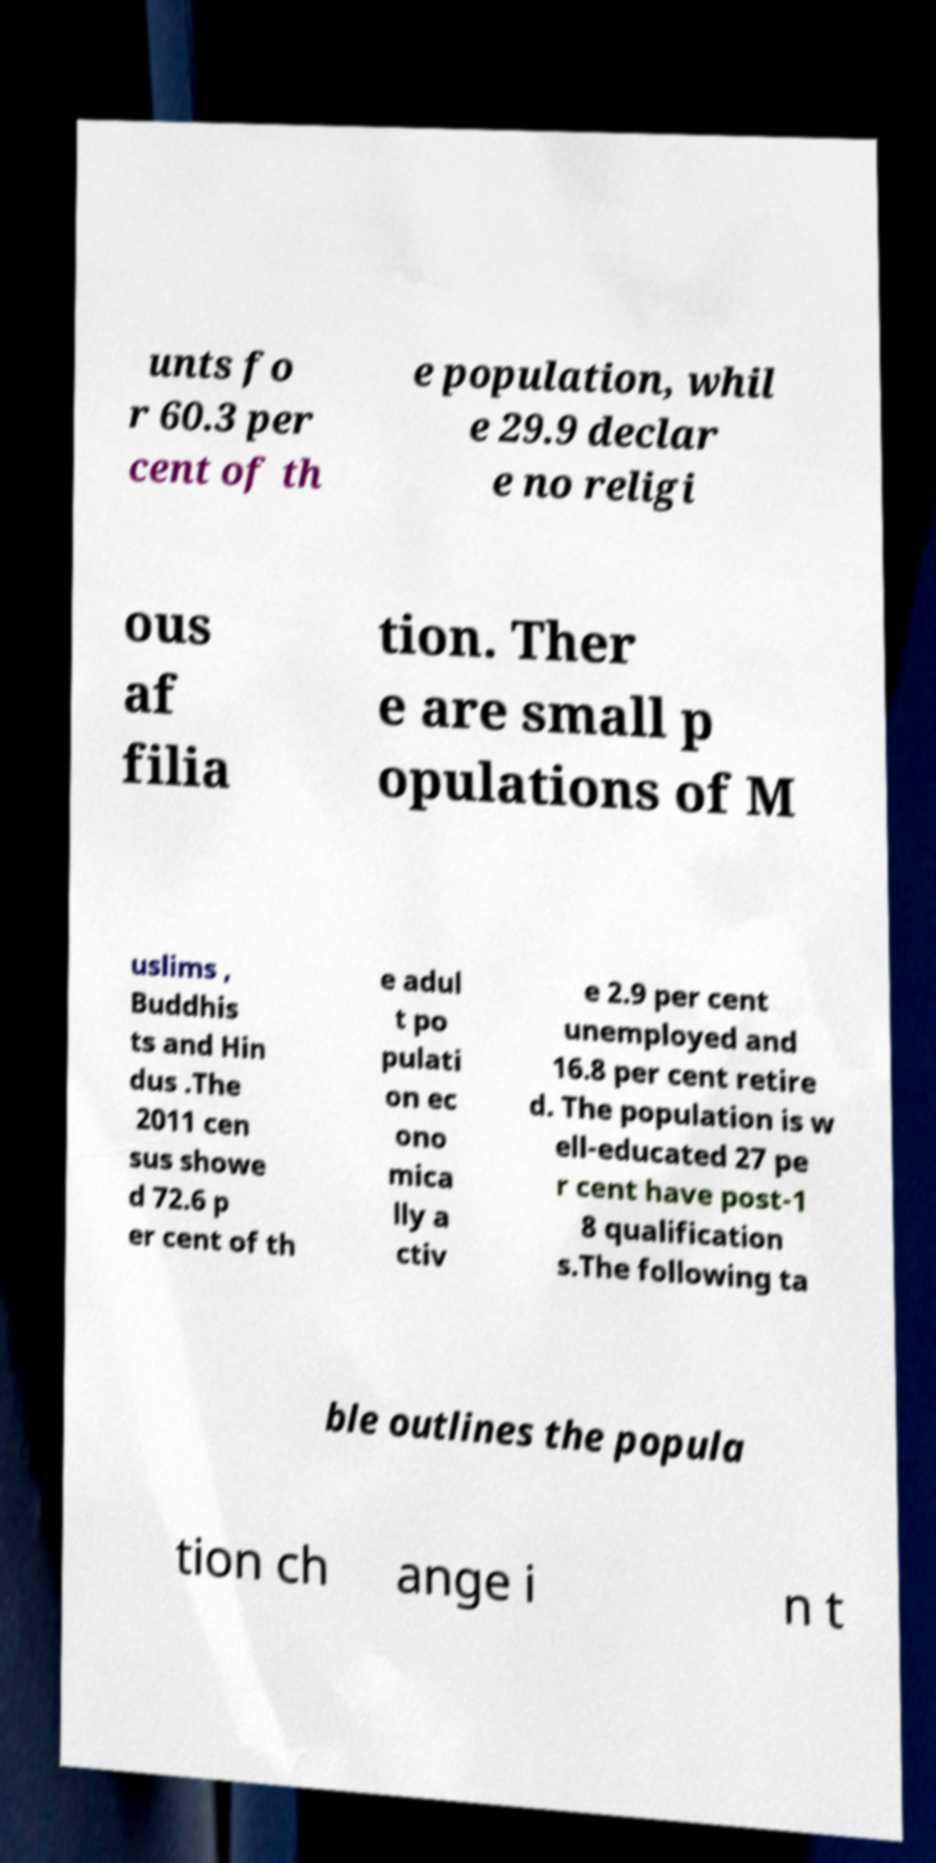Could you assist in decoding the text presented in this image and type it out clearly? unts fo r 60.3 per cent of th e population, whil e 29.9 declar e no religi ous af filia tion. Ther e are small p opulations of M uslims , Buddhis ts and Hin dus .The 2011 cen sus showe d 72.6 p er cent of th e adul t po pulati on ec ono mica lly a ctiv e 2.9 per cent unemployed and 16.8 per cent retire d. The population is w ell-educated 27 pe r cent have post-1 8 qualification s.The following ta ble outlines the popula tion ch ange i n t 